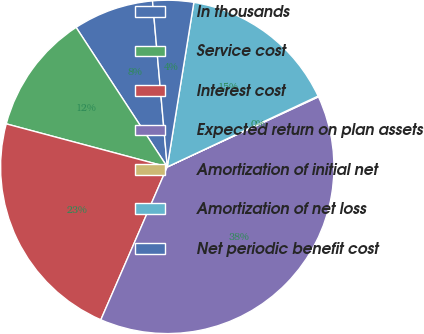<chart> <loc_0><loc_0><loc_500><loc_500><pie_chart><fcel>In thousands<fcel>Service cost<fcel>Interest cost<fcel>Expected return on plan assets<fcel>Amortization of initial net<fcel>Amortization of net loss<fcel>Net periodic benefit cost<nl><fcel>7.8%<fcel>11.63%<fcel>22.63%<fcel>38.43%<fcel>0.08%<fcel>15.46%<fcel>3.96%<nl></chart> 